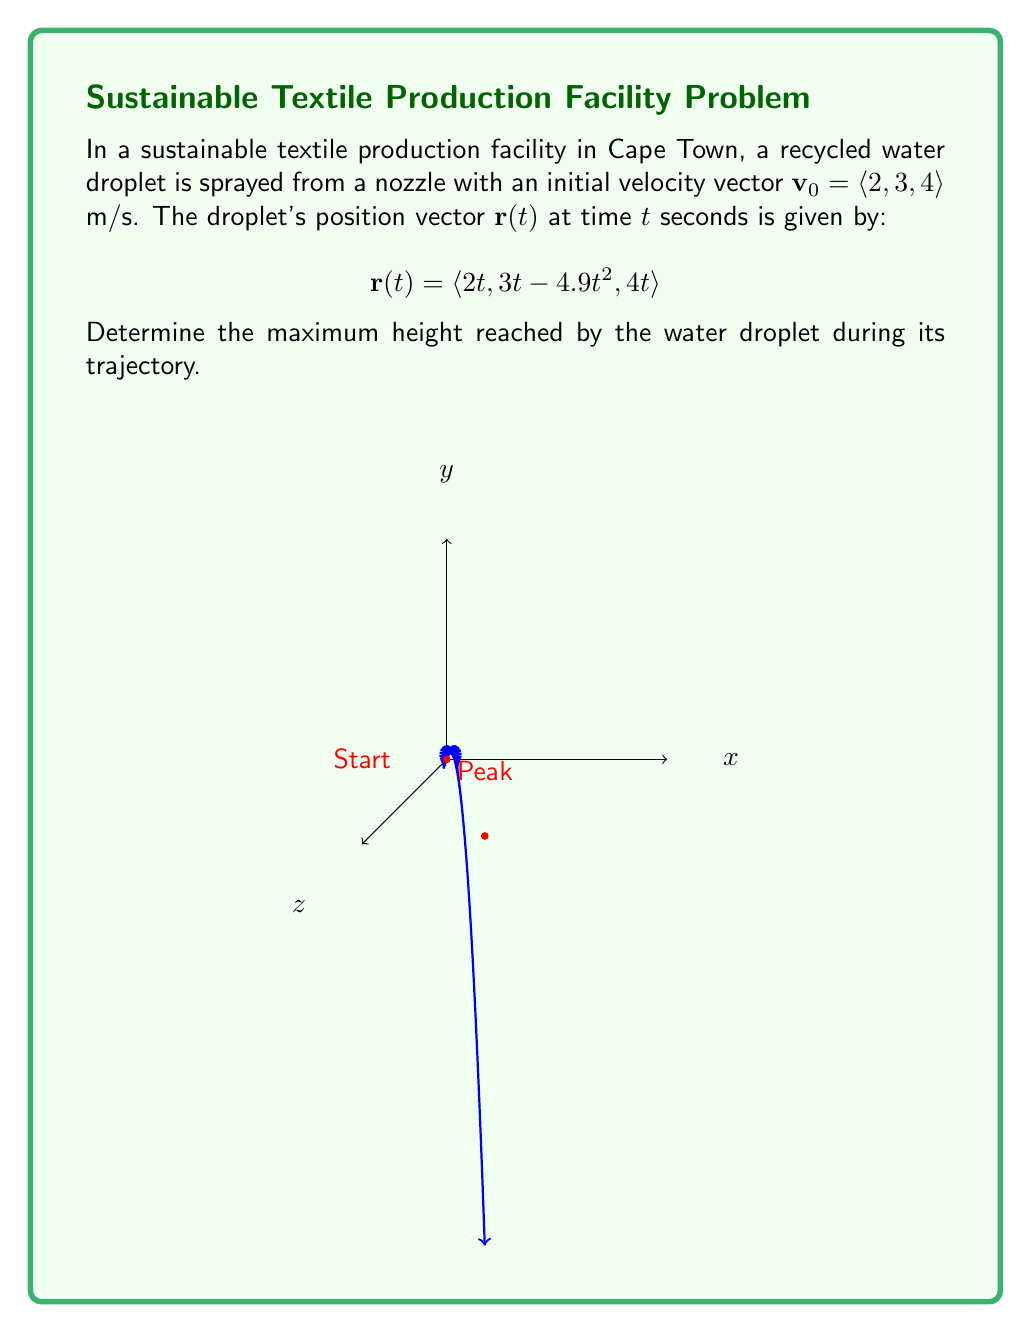Teach me how to tackle this problem. Let's approach this step-by-step:

1) The y-component of the position vector represents the vertical displacement of the droplet. We need to find the maximum value of this component.

2) The y-component is given by: $y(t) = 3t - 4.9t^2$

3) To find the maximum height, we need to find where the derivative of y(t) with respect to t equals zero:

   $\frac{dy}{dt} = 3 - 9.8t$

4) Set this equal to zero and solve for t:

   $3 - 9.8t = 0$
   $-9.8t = -3$
   $t = \frac{3}{9.8} \approx 0.306$ seconds

5) This time represents when the droplet reaches its maximum height. To find the actual height, we substitute this t-value back into the original y(t) equation:

   $y(0.306) = 3(0.306) - 4.9(0.306)^2$
             $= 0.918 - 0.458$
             $= 0.46$ meters

6) Therefore, the maximum height reached by the water droplet is approximately 0.46 meters.
Answer: 0.46 m 